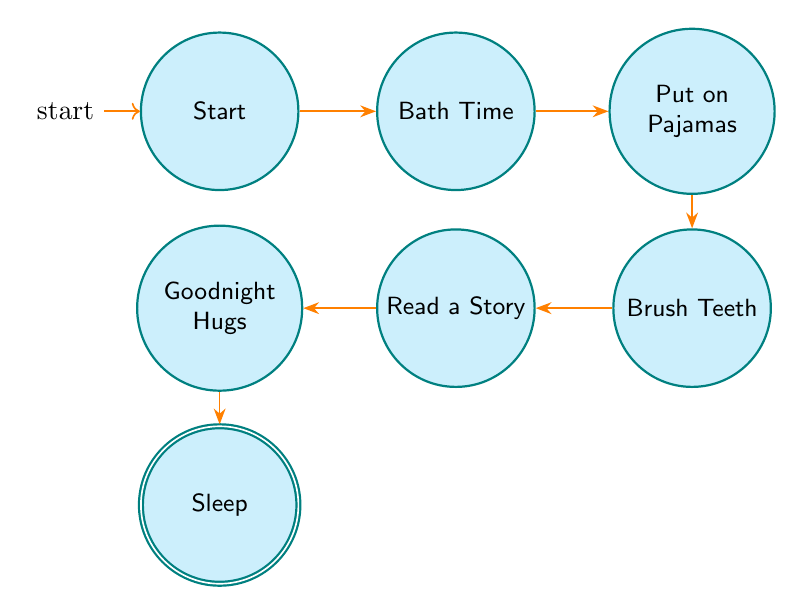What is the first state in the bedtime routine? The first state, also known as the initial state, is labeled "Start." This is indicated in the diagram by the state that has an initial marker.
Answer: Start How many states are there in total? To find the total number of states, we identify each state listed in the diagram. The states are: Start, Bath Time, Put on Pajamas, Brush Teeth, Read a Story, Goodnight Hugs, and Sleep. Counting these gives a total of 7 states.
Answer: 7 Which state comes after "Brush Teeth"? The state that follows "Brush Teeth" can be determined by looking at the transition that leads out of the "Brush Teeth" state in the diagram. The next state is "Read a Story."
Answer: Read a Story What is the last state in the bedtime routine? The last state, often identified as the accepting state, is indicated in the diagram. It is "Sleep," which is the final step once all previous steps have been completed.
Answer: Sleep Which state is directly connected to "Goodnight Hugs"? To find the state directly connected to "Goodnight Hugs," we look for the transition that emanates from "Goodnight Hugs." The state that follows is "Sleep."
Answer: Sleep What transition occurs from "Put on Pajamas"? The transition that follows the "Put on Pajamas" state leads to "Brush Teeth." This can be confirmed by tracing the directed edges out from the "Put on Pajamas" node in the diagram.
Answer: Brush Teeth How many transitions are in this diagram? To determine the number of transitions, we count each directed edge connecting the states. The transitions are: Start to Bath Time, Bath Time to Put on Pajamas, Put on Pajamas to Brush Teeth, Brush Teeth to Read a Story, Read a Story to Goodnight Hugs, and Goodnight Hugs to Sleep. This totals 6 transitions.
Answer: 6 Which state precedes "Read a Story"? The state preceding "Read a Story" can be found by identifying the transition leading into it. The state before it is "Brush Teeth," which connects directly to "Read a Story."
Answer: Brush Teeth What is the state where the child brushes their teeth? The state specifically dedicated to this activity is labeled "Brush Teeth" in the diagram. This can be directly identified as one of the defined states of the bedtime routine.
Answer: Brush Teeth 